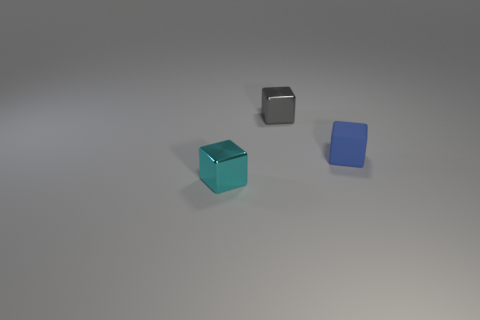Add 2 blue matte things. How many objects exist? 5 Subtract 0 purple balls. How many objects are left? 3 Subtract all large green objects. Subtract all small blue blocks. How many objects are left? 2 Add 3 tiny blue things. How many tiny blue things are left? 4 Add 2 small blue objects. How many small blue objects exist? 3 